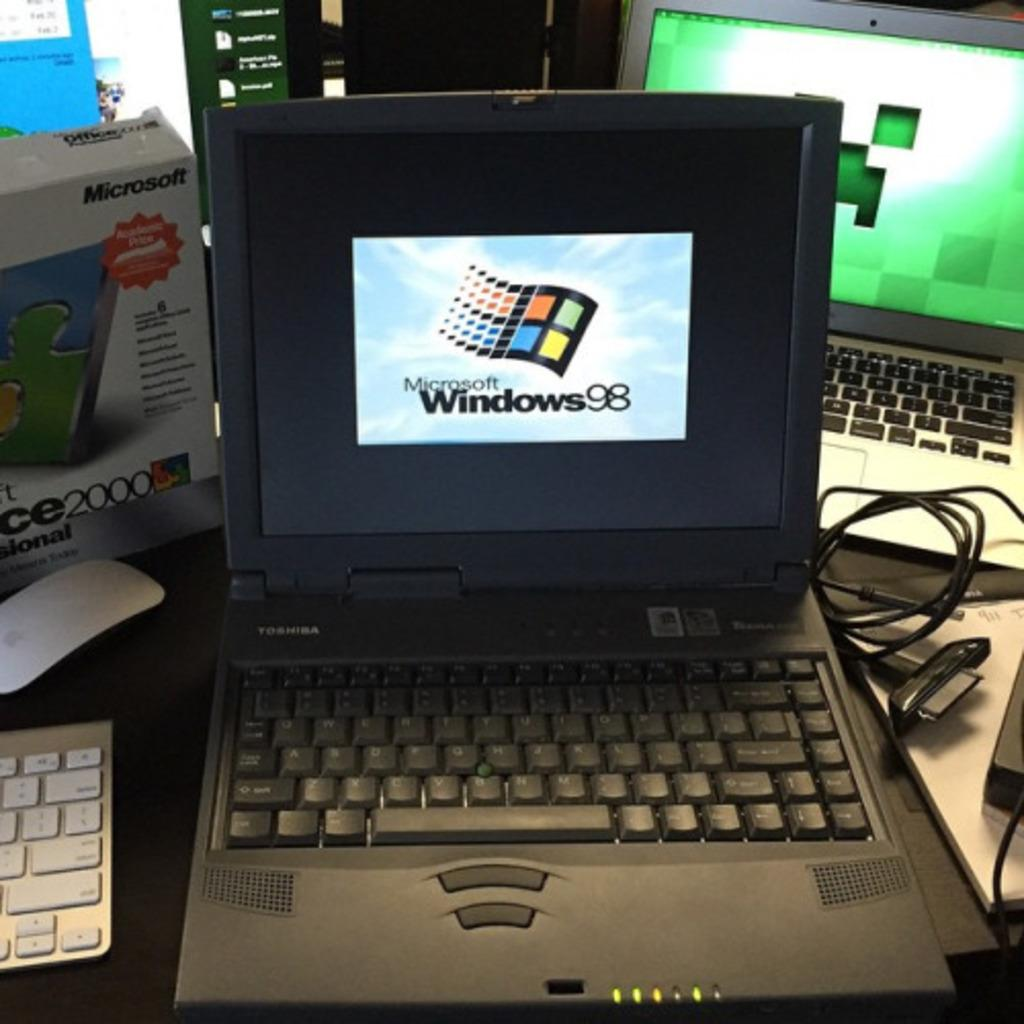<image>
Create a compact narrative representing the image presented. A Toshiba shows Windows 98 on its screen. 